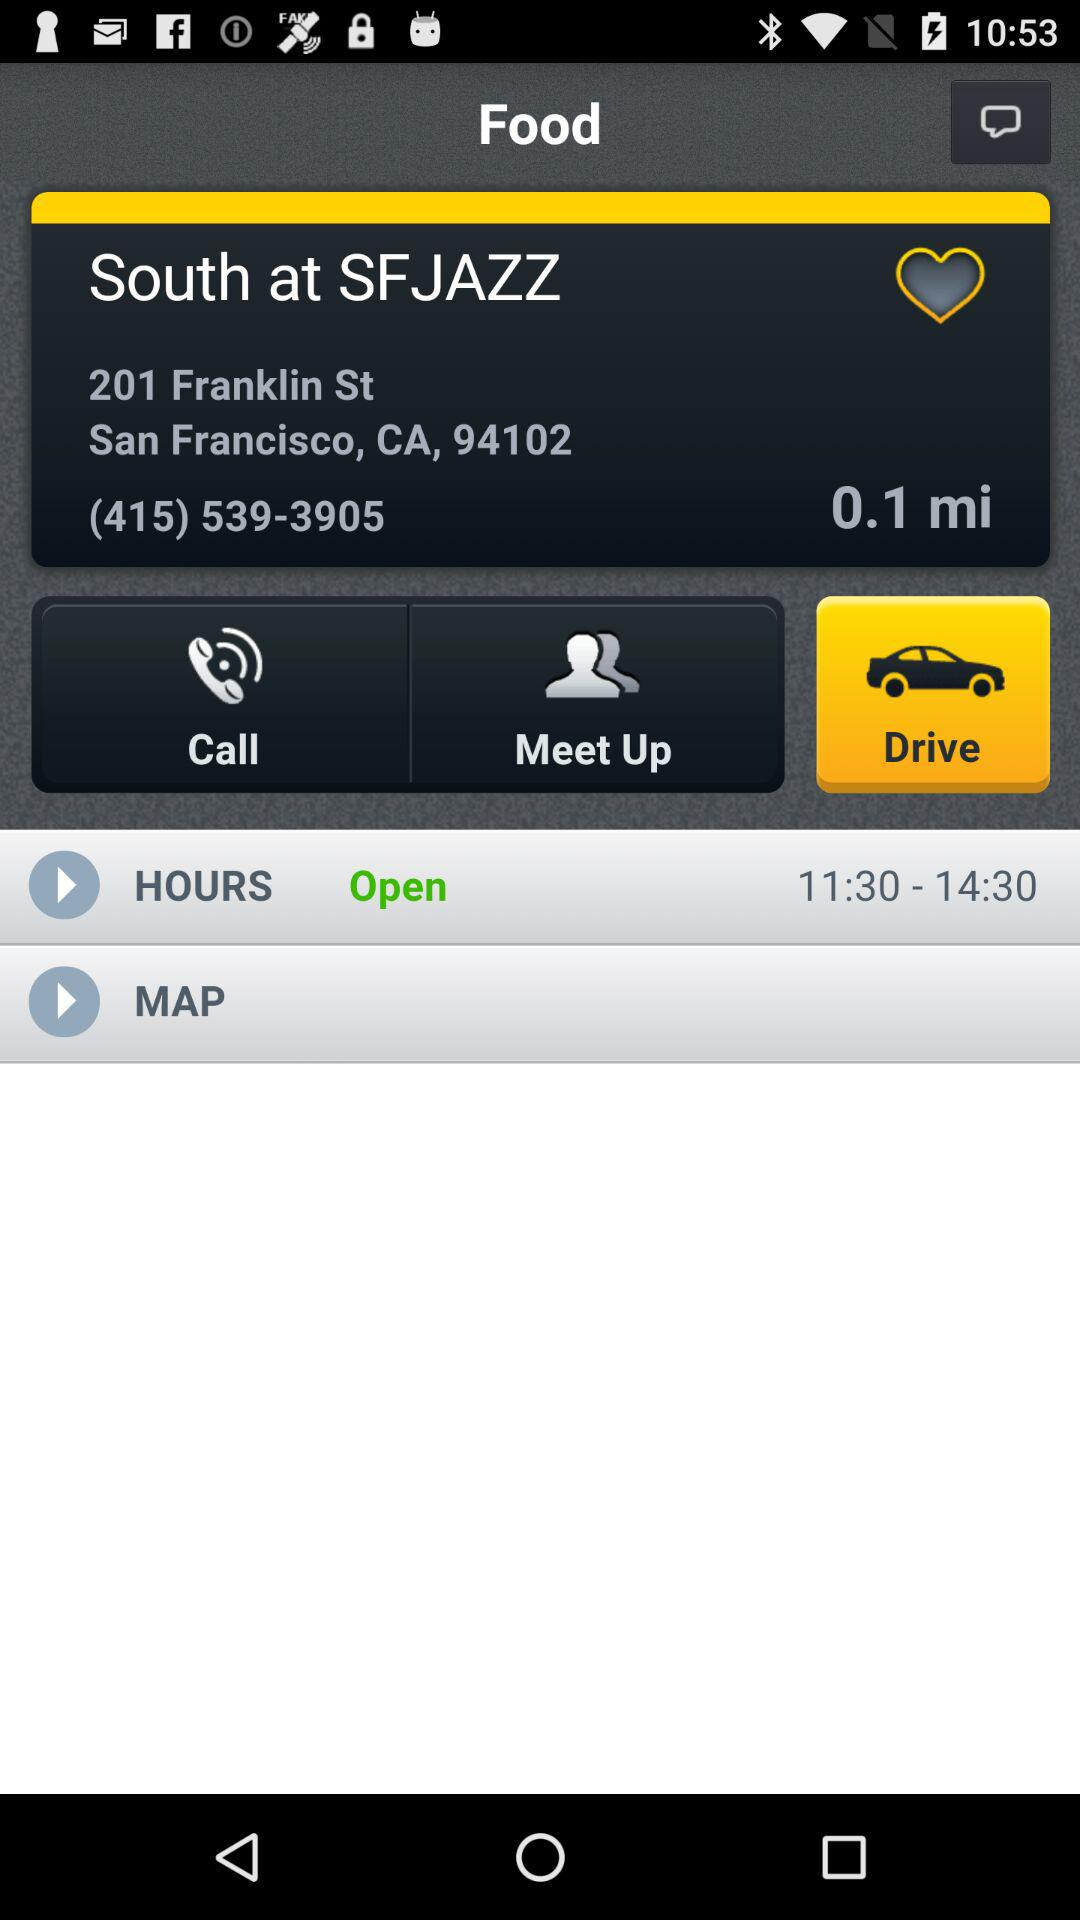What is the address given? The address is 201 Franklin St., San Francisco, CA 94102. 